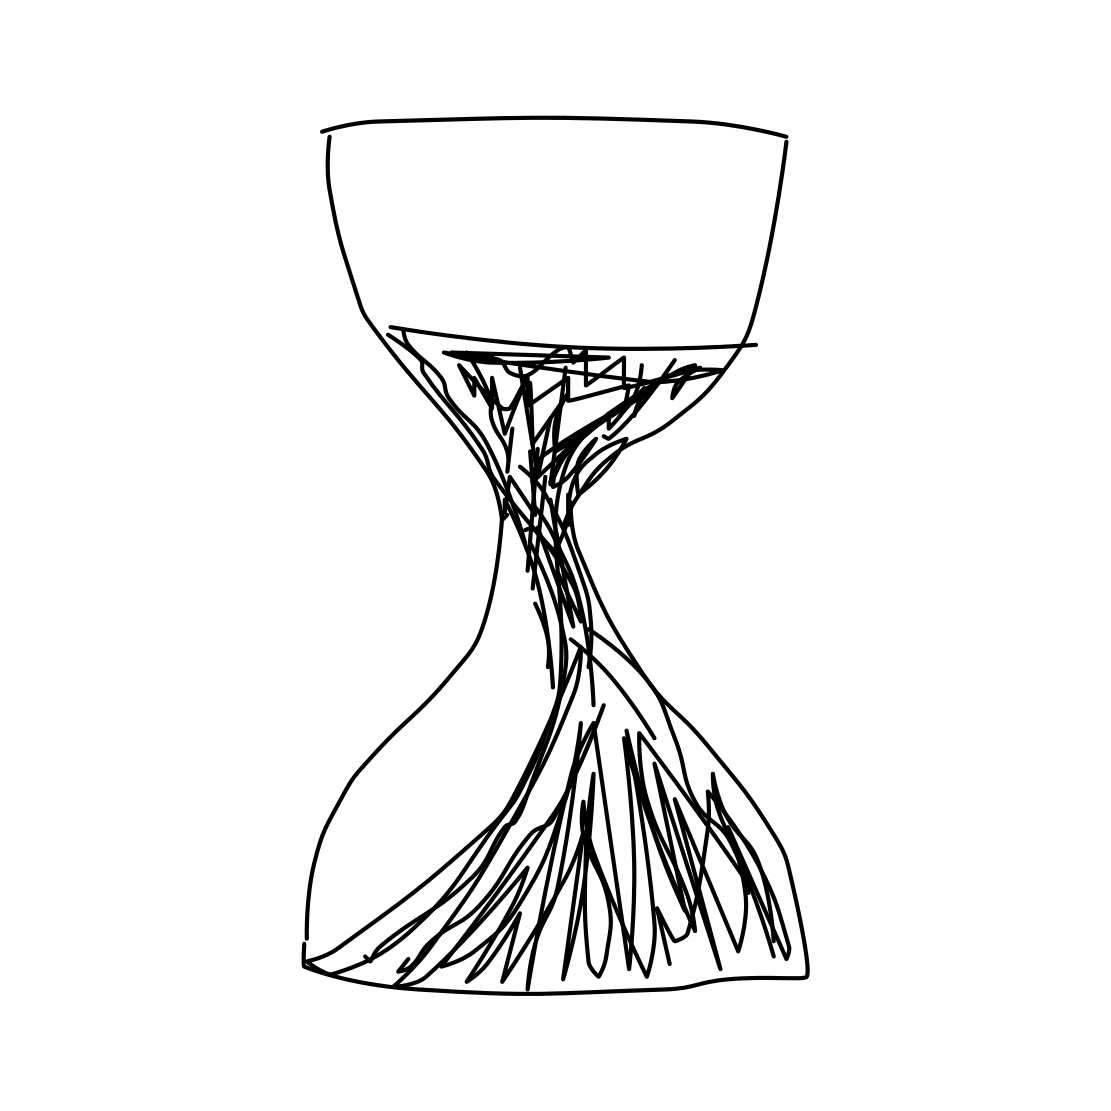Is this a hourglass in the image? Yes 